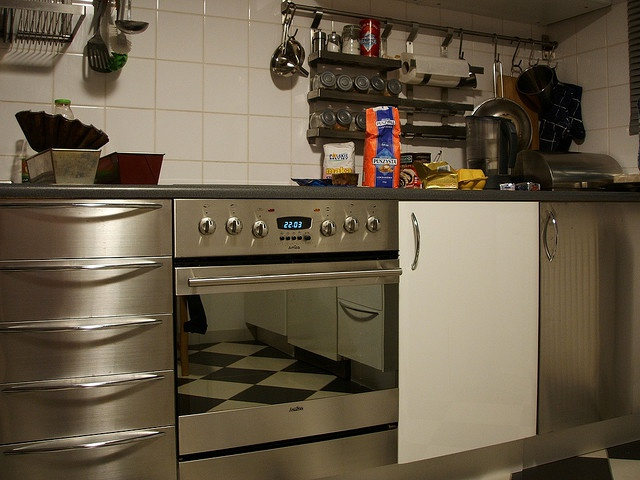Describe the objects in this image and their specific colors. I can see oven in black and gray tones, bottle in black, maroon, gray, and brown tones, bottle in black and gray tones, spoon in black and gray tones, and bottle in black, gray, darkgreen, and tan tones in this image. 